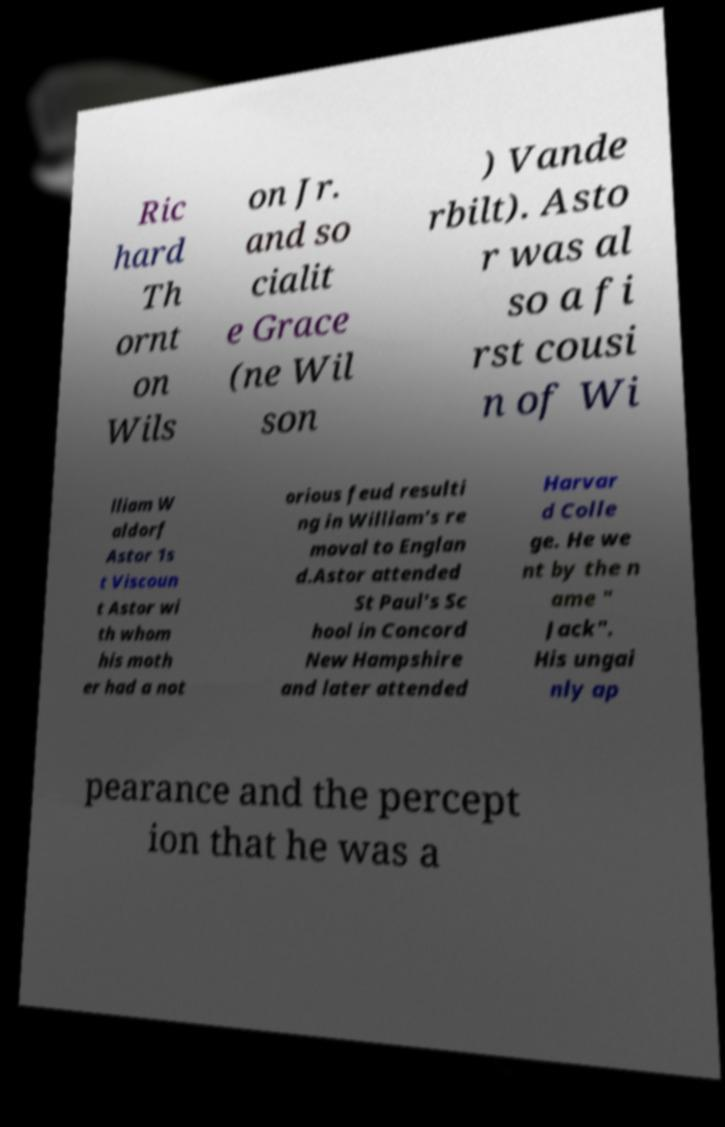Can you accurately transcribe the text from the provided image for me? Ric hard Th ornt on Wils on Jr. and so cialit e Grace (ne Wil son ) Vande rbilt). Asto r was al so a fi rst cousi n of Wi lliam W aldorf Astor 1s t Viscoun t Astor wi th whom his moth er had a not orious feud resulti ng in William's re moval to Englan d.Astor attended St Paul's Sc hool in Concord New Hampshire and later attended Harvar d Colle ge. He we nt by the n ame " Jack". His ungai nly ap pearance and the percept ion that he was a 